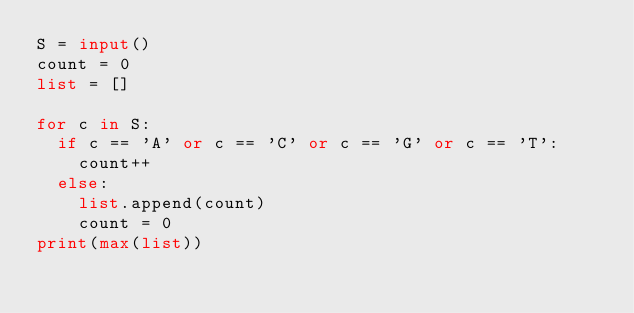<code> <loc_0><loc_0><loc_500><loc_500><_Python_>S = input()
count = 0
list = []

for c in S:
  if c == 'A' or c == 'C' or c == 'G' or c == 'T':
    count++
  else:
    list.append(count)
    count = 0
print(max(list))
    </code> 